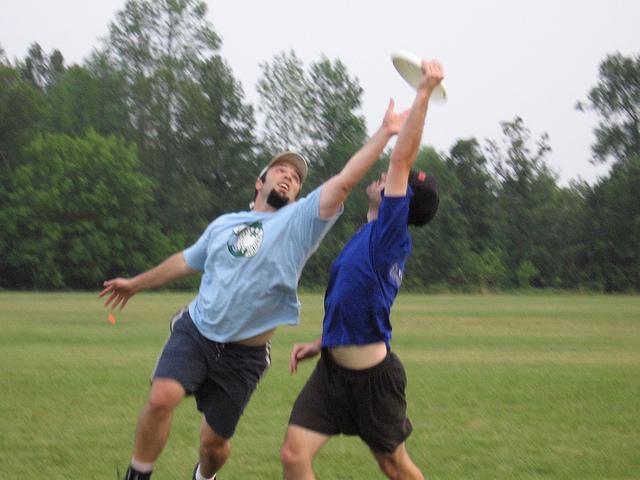Are both mean wearing hats?
Quick response, please. Yes. How many people are wearing shorts?
Short answer required. 2. Is there romance between these two?
Quick response, please. No. What is the color of the men's shorts?
Answer briefly. Black. What color is the stripe going down the man's shorts who is jumping in the air?
Short answer required. White. Who caught the Frisbee?
Concise answer only. Man on right. Is it warm?
Concise answer only. Yes. 